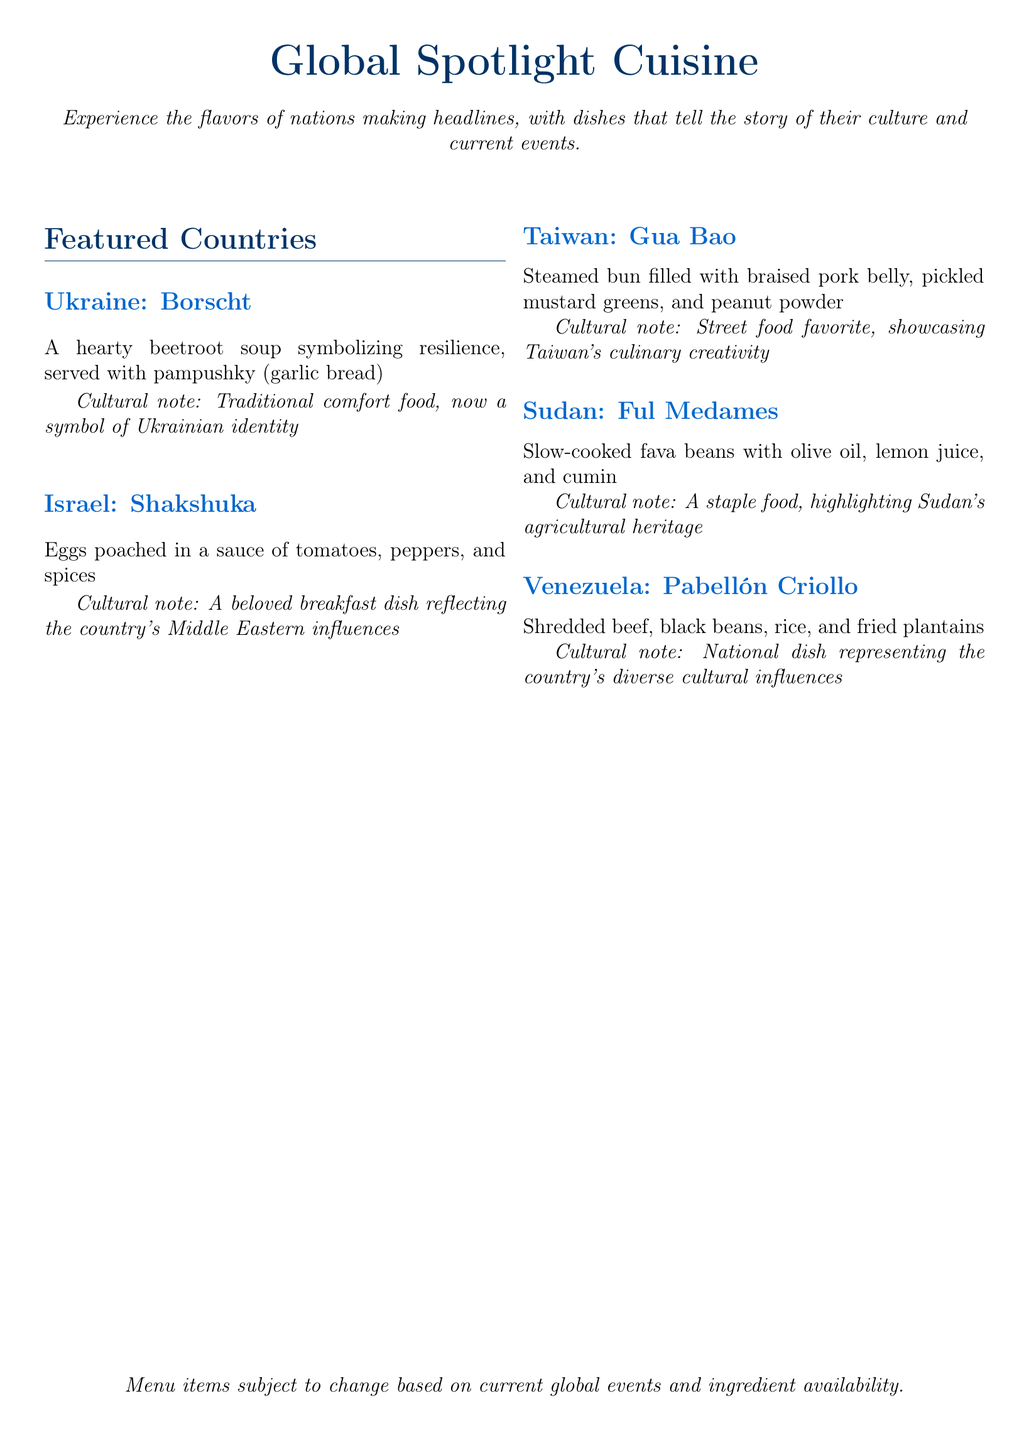What is the name of the Ukrainian dish? The document mentions "Borscht" as the dish from Ukraine.
Answer: Borscht What is a traditional accompaniment to Borscht? The document states that Borscht is served with "pampushky".
Answer: pampushky What is the main ingredient in Shakshuka? The document indicates that the main ingredient of Shakshuka is "eggs".
Answer: eggs How is Gua Bao typically prepared? The document describes Gua Bao as a "steamed bun".
Answer: steamed bun What type of beans are used in Ful Medames? The document refers to "fava beans" as the main ingredient in Ful Medames.
Answer: fava beans Which country does Pabellón Criollo originate from? The document states it is the national dish of "Venezuela".
Answer: Venezuela What is the cultural significance of Borscht? The document mentions it as a symbol of "Ukrainian identity".
Answer: Ukrainian identity How many featured countries are mentioned in the menu? The document lists a total of "five" featured countries.
Answer: five What does the menu indicate about the menu items? The document notes that menu items are "subject to change".
Answer: subject to change 